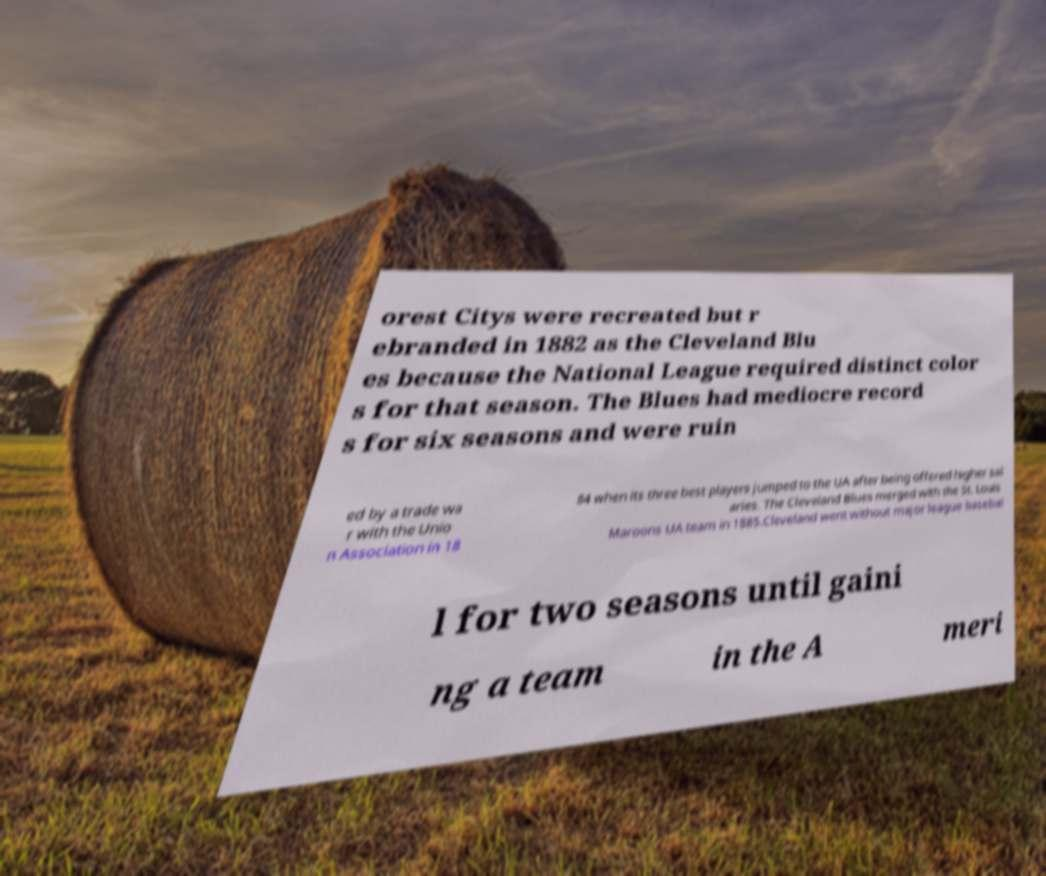Can you accurately transcribe the text from the provided image for me? orest Citys were recreated but r ebranded in 1882 as the Cleveland Blu es because the National League required distinct color s for that season. The Blues had mediocre record s for six seasons and were ruin ed by a trade wa r with the Unio n Association in 18 84 when its three best players jumped to the UA after being offered higher sal aries. The Cleveland Blues merged with the St. Louis Maroons UA team in 1885.Cleveland went without major league basebal l for two seasons until gaini ng a team in the A meri 